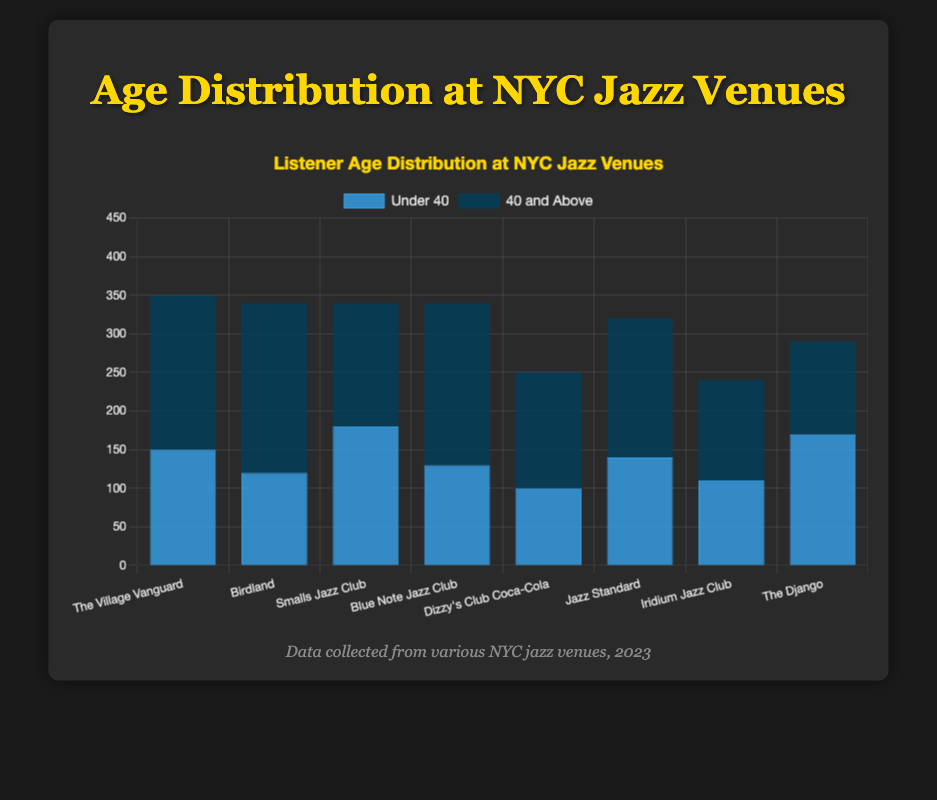Which venue has the highest number of listeners under 40? The chart shows different blue bars representing the number of listeners under 40 at each venue. The tallest blue bar is at "Smalls Jazz Club" with 180 listeners.
Answer: Smalls Jazz Club Which venue has the highest number of listeners aged 40 and above? The chart shows different dark blue bars representing the number of listeners aged 40 and above at each venue. The tallest dark blue bar is at "Birdland" with 220 listeners.
Answer: Birdland What is the total number of listeners at The Village Vanguard? To find the total listeners at "The Village Vanguard", add the numbers represented by the blue and dark blue bars: 150 (under 40) + 200 (40 and above).
Answer: 350 Which venue has the smallest age group difference between under 40 and above 40 listeners? For each venue, calculate the absolute difference between the blue and dark blue bars. The smallest difference is at "Iridium Jazz Club" with 20 (110 under 40 vs. 130 above 40).
Answer: Iridium Jazz Club Among "The Django" and "Jazz Standard," which venue has more total listeners? Sum up the listeners for both under 40 and above 40 categories at "The Django" (170 + 120 = 290) and "Jazz Standard" (140 + 180 = 320), and compare the totals.
Answer: Jazz Standard What is the average number of under 40 listeners across all venues? Sum up the under 40 listeners from all venues (150 + 120 + 180 + 130 + 100 + 140 + 110 + 170) and divide by the number of venues (8). The sum is 1100, so the average is 1100 / 8 = 137.5.
Answer: 137.5 Which venue attracted more listeners: "Dizzy's Club Coca-Cola" or "Blue Note Jazz Club"? Sum up the listeners for both age groups at "Dizzy's Club Coca-Cola" (100 + 150 = 250) and "Blue Note Jazz Club" (130 + 210 = 340), and compare the totals.
Answer: Blue Note Jazz Club What is the percentage of under 40 listeners at Birdland? Calculate the percentage of under 40 listeners at Birdland: (120 / (120 + 220)) * 100 = (120 / 340) * 100 ≈ 35.29%.
Answer: 35.29% Which venue shows a higher proportion of older listeners relative to younger listeners, "The Village Vanguard" or "Birdland"? Compare the ratio of above 40 to under 40 listeners at both venues: 
- The Village Vanguard: 200 / 150 ≈ 1.33 
- Birdland: 220 / 120 ≈ 1.83. 
Birdland has a higher ratio.
Answer: Birdland 